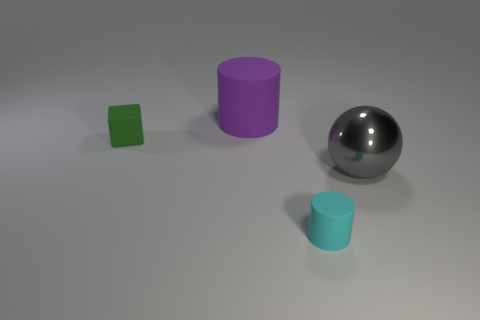There is a tiny matte thing in front of the large ball; is its shape the same as the big metallic object?
Your answer should be compact. No. What number of things are large cylinders or big metal objects?
Ensure brevity in your answer.  2. What is the object that is both left of the small cyan thing and right of the cube made of?
Provide a succinct answer. Rubber. Does the gray sphere have the same size as the green cube?
Offer a very short reply. No. There is a rubber cylinder to the right of the big purple matte cylinder behind the tiny green block; what size is it?
Give a very brief answer. Small. What number of things are to the left of the big gray object and in front of the green thing?
Your response must be concise. 1. Is there a large gray metallic ball to the left of the matte cylinder behind the small rubber thing that is left of the cyan matte object?
Keep it short and to the point. No. There is a green thing that is the same size as the cyan cylinder; what is its shape?
Your response must be concise. Cube. Are there any matte objects of the same color as the large cylinder?
Offer a terse response. No. Do the gray metal object and the green thing have the same shape?
Keep it short and to the point. No. 